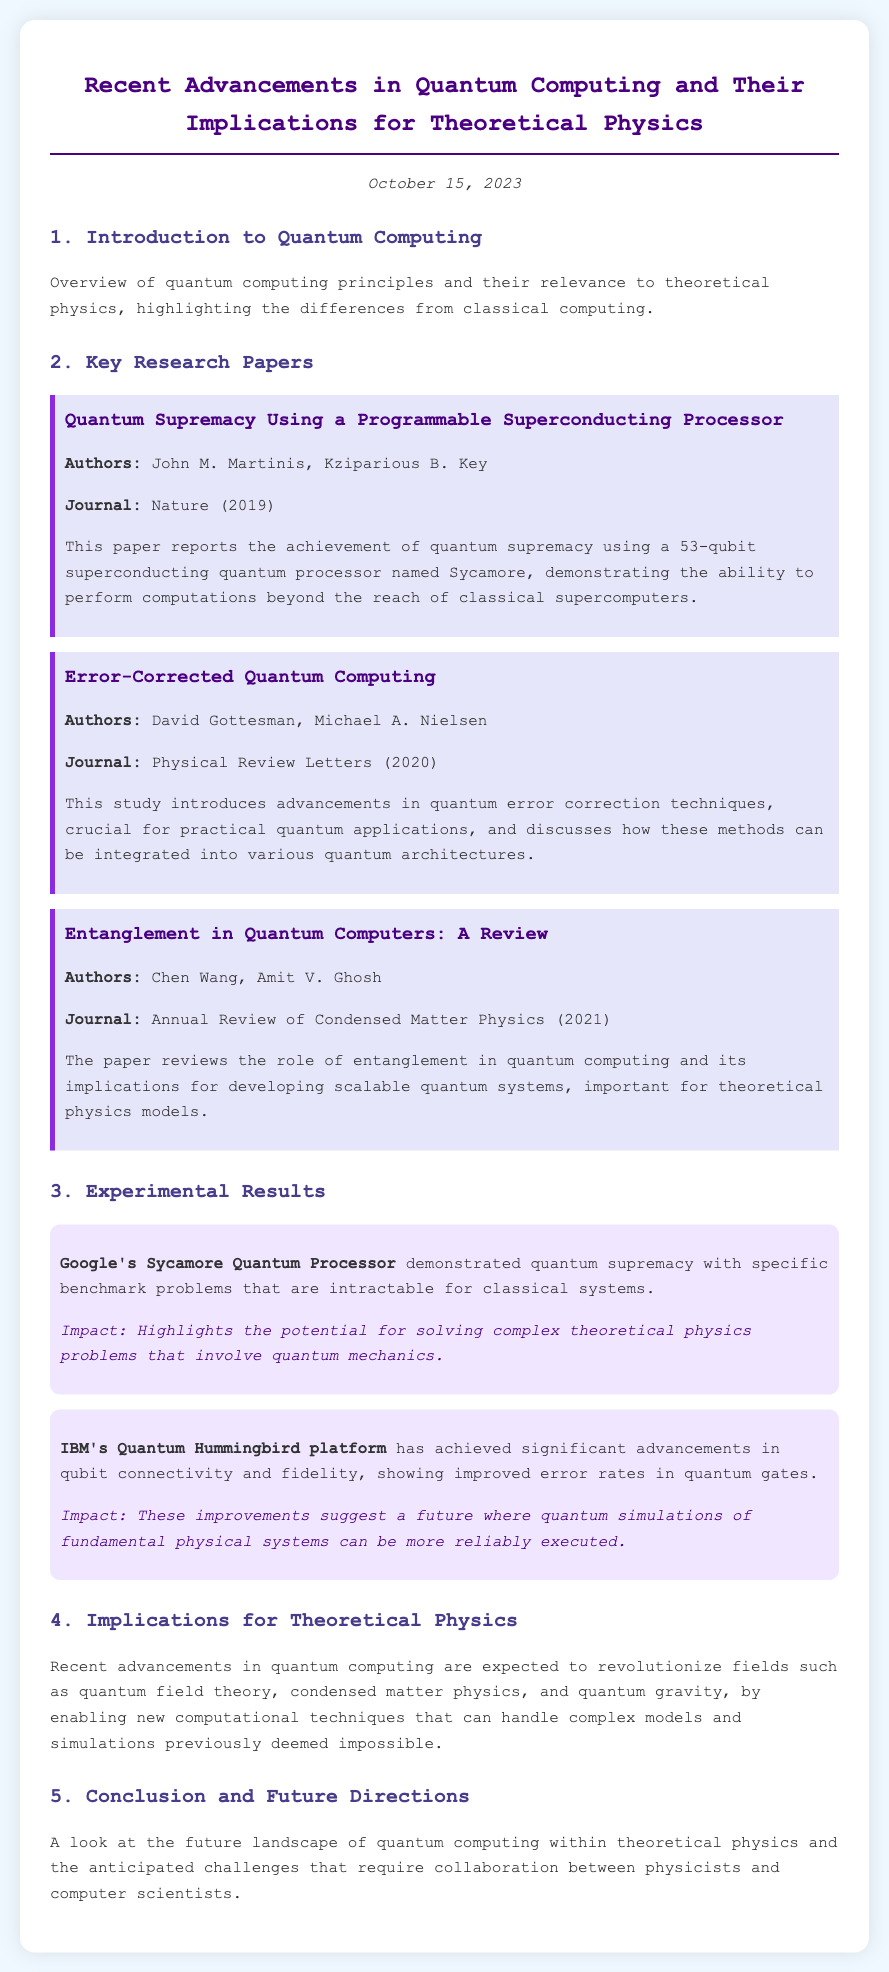What is the title of the agenda? The title of the agenda is listed at the top of the document.
Answer: Recent Advancements in Quantum Computing and Their Implications for Theoretical Physics Who are the authors of the paper titled "Error-Corrected Quantum Computing"? The authors of this paper are specifically mentioned in the section about key research papers.
Answer: David Gottesman, Michael A. Nielsen Which quantum processor demonstrated quantum supremacy? The document provides a specific name of the quantum processor that achieved this feat.
Answer: Sycamore What year was the paper "Entanglement in Quantum Computers: A Review" published? The publication year is stated in the details of the key research papers section.
Answer: 2021 What significant advancement is mentioned regarding IBM's Quantum Hummingbird platform? This particular achievement is highlighted in the experimental results section.
Answer: Improved error rates in quantum gates What implications are discussed for theoretical physics? The document outlines expected impacts on specific areas of theoretical physics based on advancements in quantum computing.
Answer: Revolutionize quantum field theory, condensed matter physics, and quantum gravity What type of document is this? The content structure and focus indicate the type of document presented here.
Answer: Agenda How many research papers are summarized in the document? The list of key research papers reveals the total number included in the document.
Answer: Three 